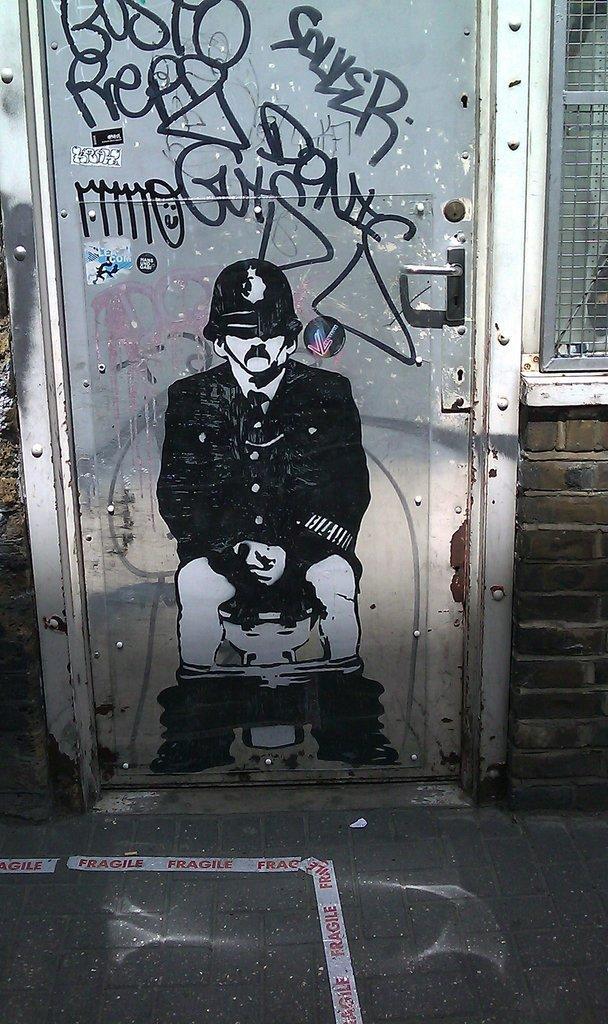In one or two sentences, can you explain what this image depicts? In the image we can see the wall and on the wall we can see the picture of the person wearing clothes and helmet. Here we can see floor, mesh and brick wall. 